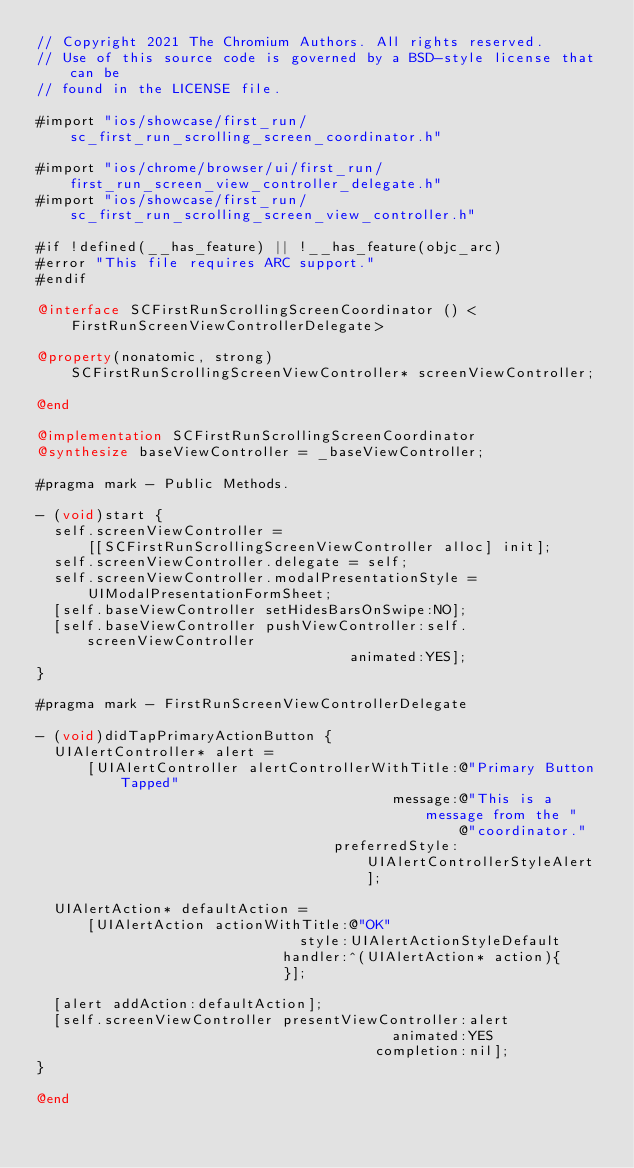<code> <loc_0><loc_0><loc_500><loc_500><_ObjectiveC_>// Copyright 2021 The Chromium Authors. All rights reserved.
// Use of this source code is governed by a BSD-style license that can be
// found in the LICENSE file.

#import "ios/showcase/first_run/sc_first_run_scrolling_screen_coordinator.h"

#import "ios/chrome/browser/ui/first_run/first_run_screen_view_controller_delegate.h"
#import "ios/showcase/first_run/sc_first_run_scrolling_screen_view_controller.h"

#if !defined(__has_feature) || !__has_feature(objc_arc)
#error "This file requires ARC support."
#endif

@interface SCFirstRunScrollingScreenCoordinator () <
    FirstRunScreenViewControllerDelegate>

@property(nonatomic, strong)
    SCFirstRunScrollingScreenViewController* screenViewController;

@end

@implementation SCFirstRunScrollingScreenCoordinator
@synthesize baseViewController = _baseViewController;

#pragma mark - Public Methods.

- (void)start {
  self.screenViewController =
      [[SCFirstRunScrollingScreenViewController alloc] init];
  self.screenViewController.delegate = self;
  self.screenViewController.modalPresentationStyle =
      UIModalPresentationFormSheet;
  [self.baseViewController setHidesBarsOnSwipe:NO];
  [self.baseViewController pushViewController:self.screenViewController
                                     animated:YES];
}

#pragma mark - FirstRunScreenViewControllerDelegate

- (void)didTapPrimaryActionButton {
  UIAlertController* alert =
      [UIAlertController alertControllerWithTitle:@"Primary Button Tapped"
                                          message:@"This is a message from the "
                                                  @"coordinator."
                                   preferredStyle:UIAlertControllerStyleAlert];

  UIAlertAction* defaultAction =
      [UIAlertAction actionWithTitle:@"OK"
                               style:UIAlertActionStyleDefault
                             handler:^(UIAlertAction* action){
                             }];

  [alert addAction:defaultAction];
  [self.screenViewController presentViewController:alert
                                          animated:YES
                                        completion:nil];
}

@end
</code> 